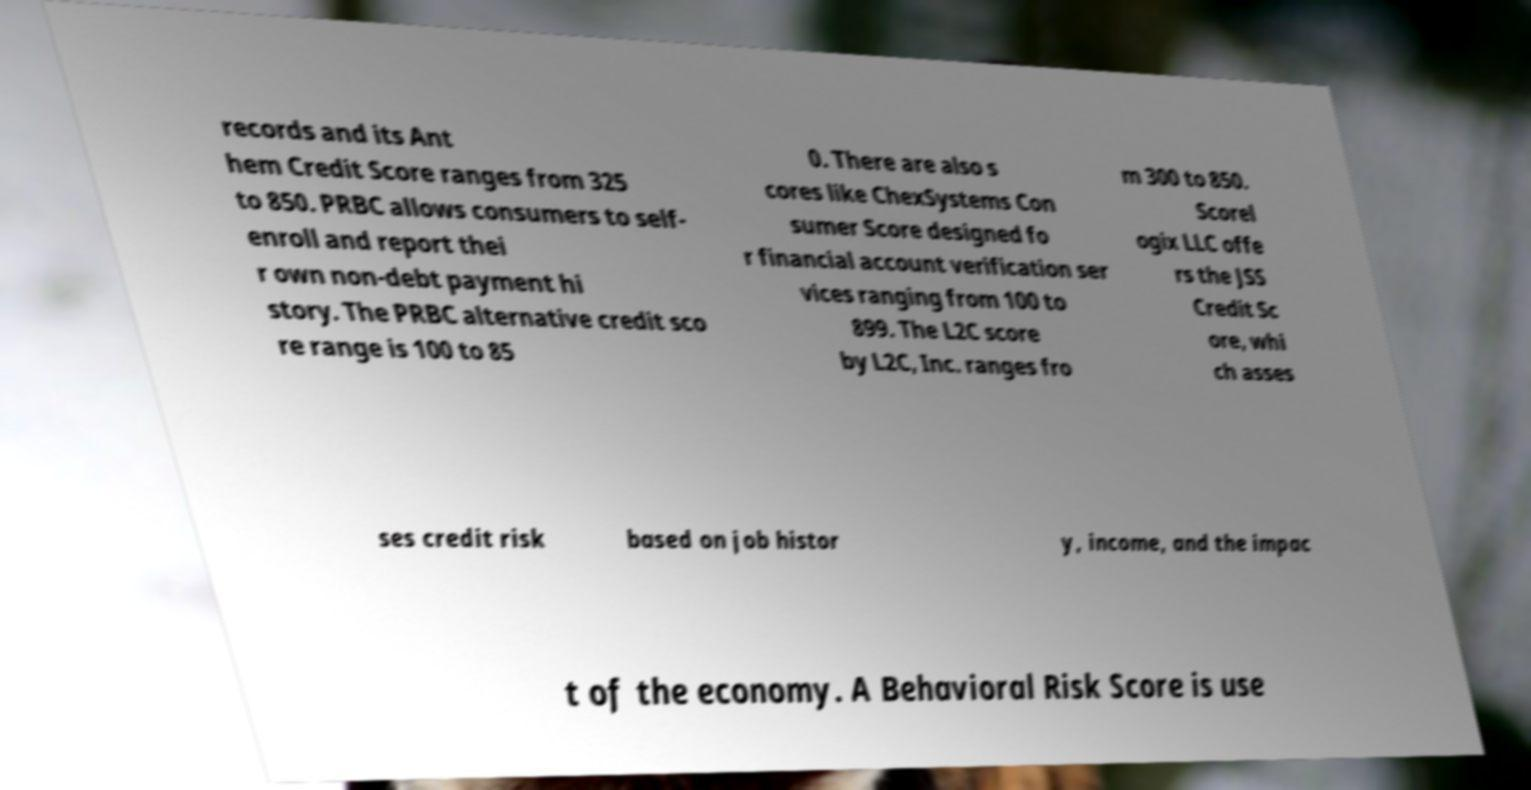Can you accurately transcribe the text from the provided image for me? records and its Ant hem Credit Score ranges from 325 to 850. PRBC allows consumers to self- enroll and report thei r own non-debt payment hi story. The PRBC alternative credit sco re range is 100 to 85 0. There are also s cores like ChexSystems Con sumer Score designed fo r financial account verification ser vices ranging from 100 to 899. The L2C score by L2C, Inc. ranges fro m 300 to 850. Scorel ogix LLC offe rs the JSS Credit Sc ore, whi ch asses ses credit risk based on job histor y, income, and the impac t of the economy. A Behavioral Risk Score is use 